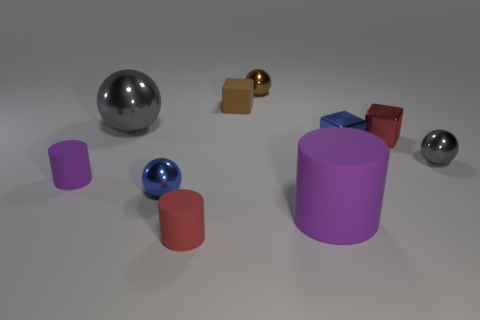Does the block to the left of the big purple cylinder have the same material as the large cylinder? Yes, it appears that both the block to the left of the large purple cylinder and the cylinder itself showcase a matte surface texture, indicating that they likely have the same material composition. 